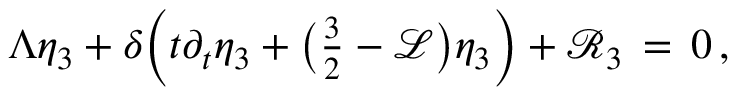<formula> <loc_0><loc_0><loc_500><loc_500>\Lambda \eta _ { 3 } + \delta \left ( t \partial _ { t } \eta _ { 3 } + \left ( { \frac { 3 } { 2 } } - \mathcal { L } \right ) \eta _ { 3 } \right ) + \mathcal { R } _ { 3 } \, = \, 0 \, ,</formula> 